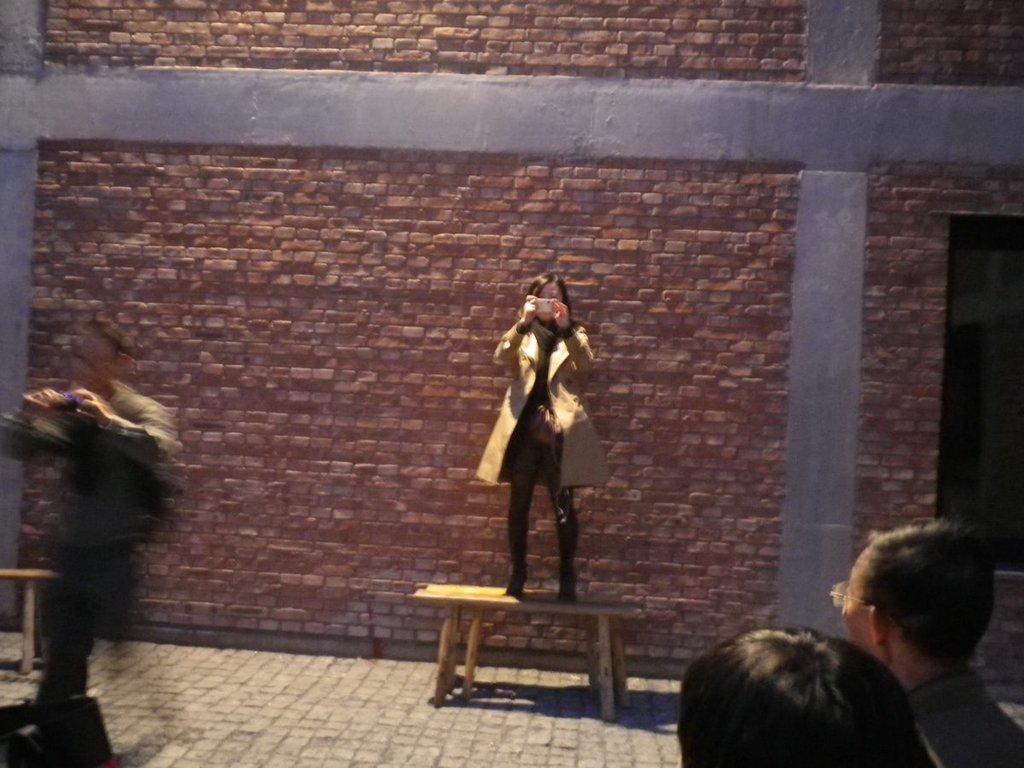Please provide a concise description of this image. In this image, I can see a person holding an object and standing on the table. At the bottom of the image, I can see the heads of two persons. On the left side of the image, there is another person holding an object. In the background, there is a wall. 